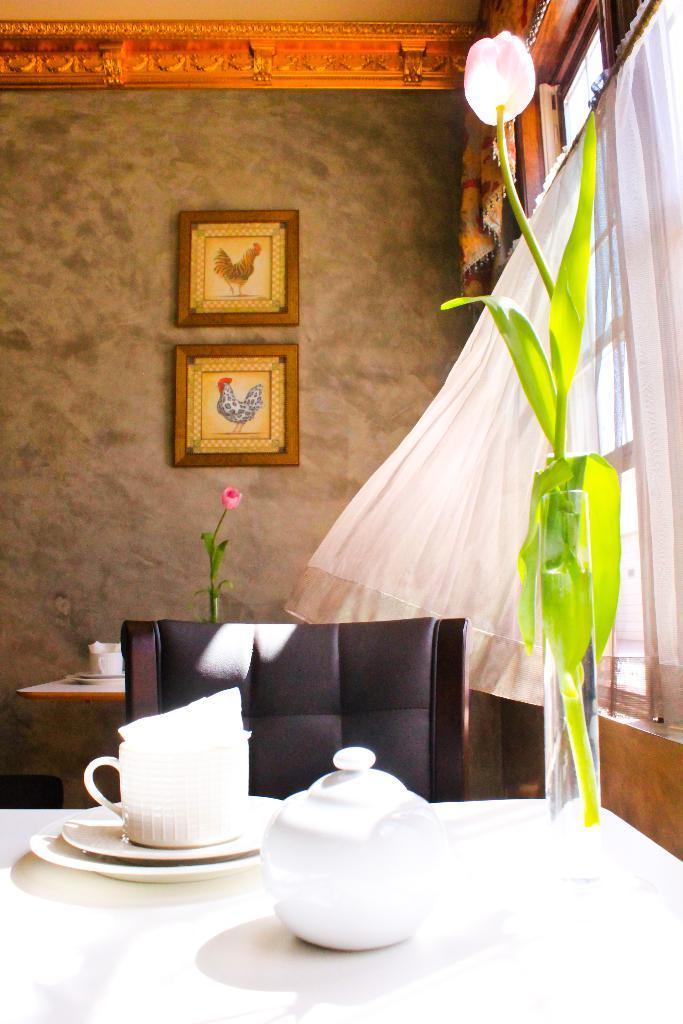In one or two sentences, can you explain what this image depicts? In this image I see a table on which there is a cup, plates, a kettle and a flower. I can also see a chair. In the background I see 2 photo frames on the wall, a window and the curtain. 